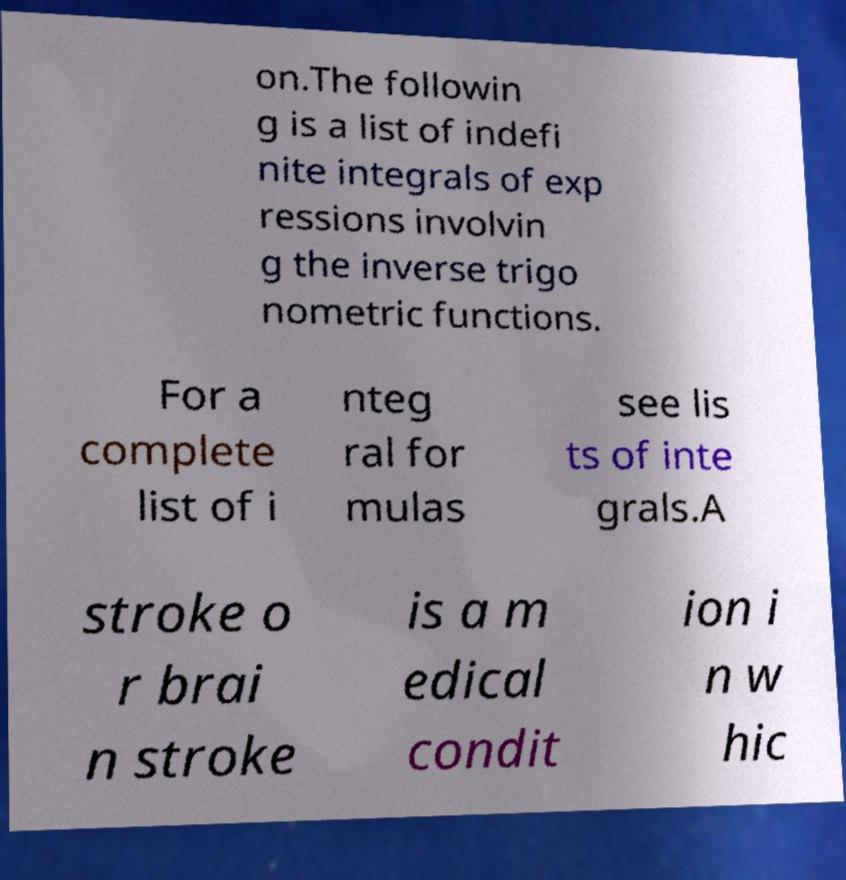What messages or text are displayed in this image? I need them in a readable, typed format. on.The followin g is a list of indefi nite integrals of exp ressions involvin g the inverse trigo nometric functions. For a complete list of i nteg ral for mulas see lis ts of inte grals.A stroke o r brai n stroke is a m edical condit ion i n w hic 